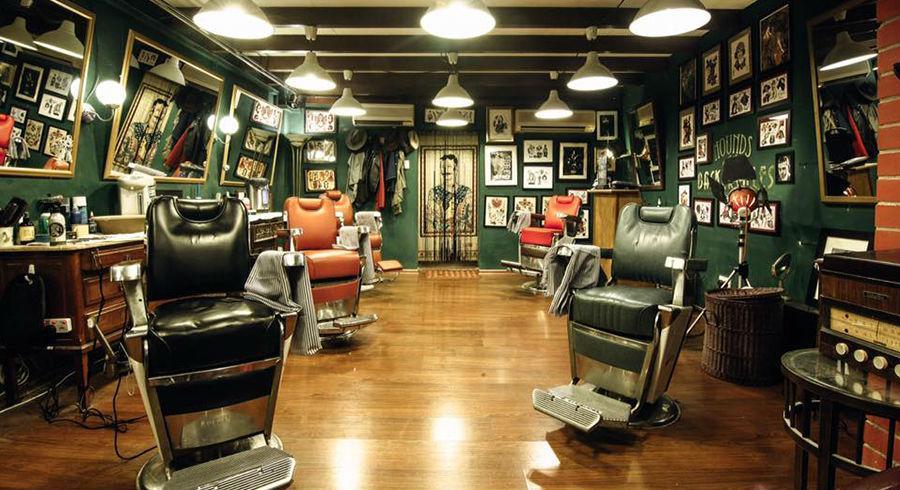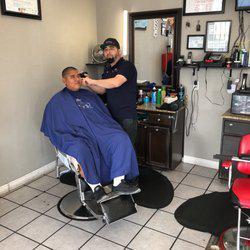The first image is the image on the left, the second image is the image on the right. Analyze the images presented: Is the assertion "There are no more than two people in total in the two shops." valid? Answer yes or no. Yes. The first image is the image on the left, the second image is the image on the right. Examine the images to the left and right. Is the description "There are people in one image but not in the other image." accurate? Answer yes or no. Yes. 